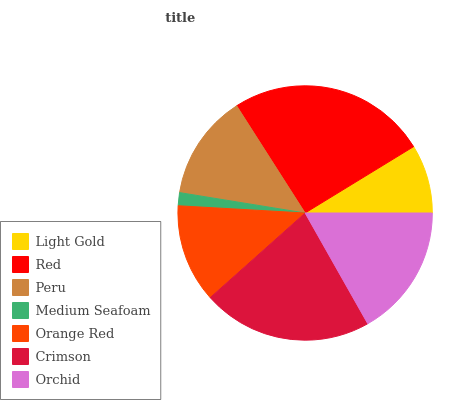Is Medium Seafoam the minimum?
Answer yes or no. Yes. Is Red the maximum?
Answer yes or no. Yes. Is Peru the minimum?
Answer yes or no. No. Is Peru the maximum?
Answer yes or no. No. Is Red greater than Peru?
Answer yes or no. Yes. Is Peru less than Red?
Answer yes or no. Yes. Is Peru greater than Red?
Answer yes or no. No. Is Red less than Peru?
Answer yes or no. No. Is Peru the high median?
Answer yes or no. Yes. Is Peru the low median?
Answer yes or no. Yes. Is Orchid the high median?
Answer yes or no. No. Is Medium Seafoam the low median?
Answer yes or no. No. 